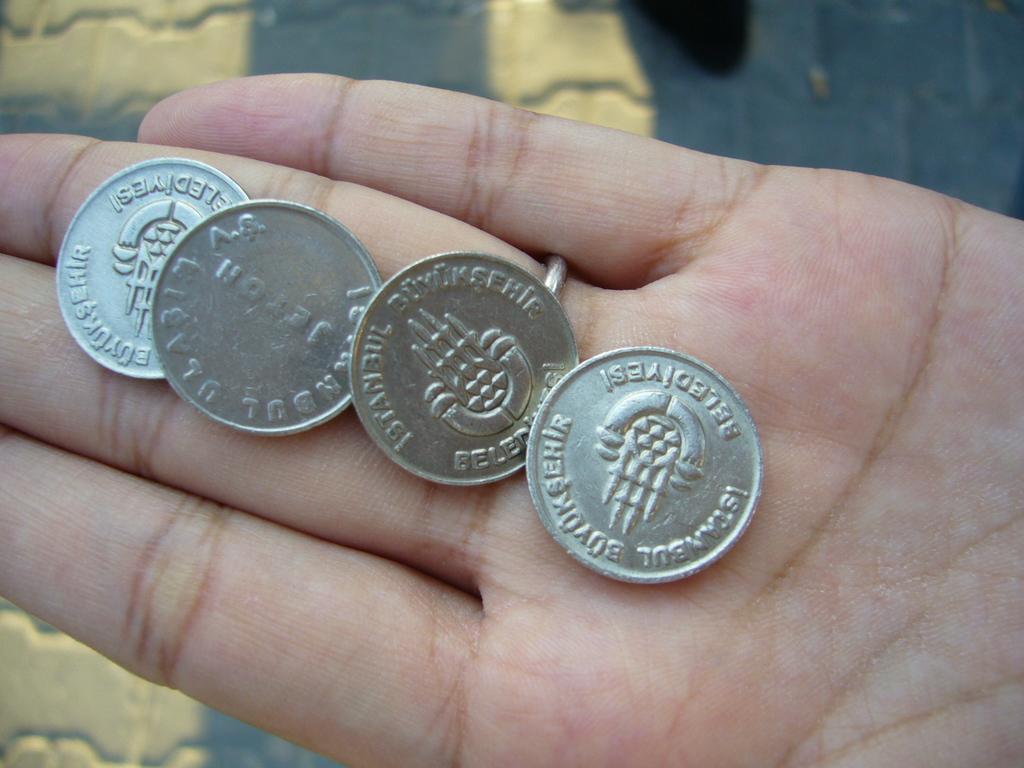How would you summarize this image in a sentence or two? There are four coins on the hand of a person. In the background, there are yellow color paintings on a surface. 